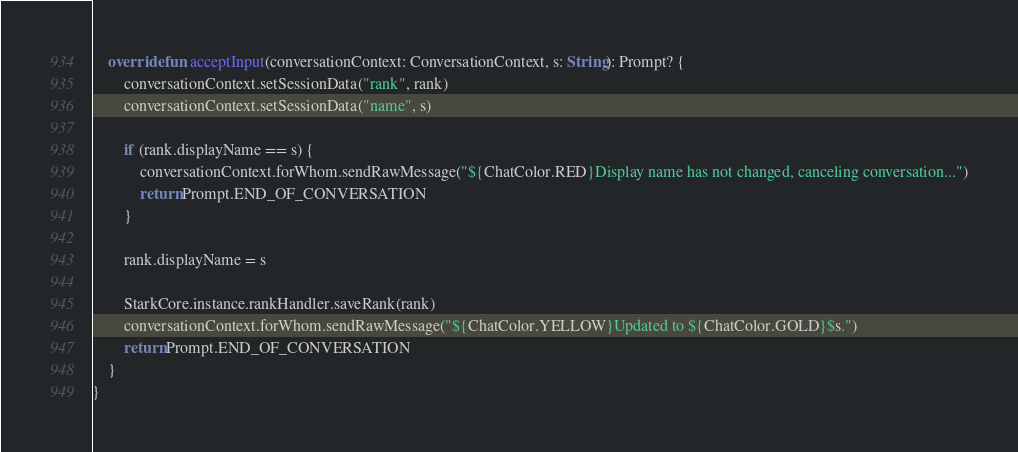<code> <loc_0><loc_0><loc_500><loc_500><_Kotlin_>
    override fun acceptInput(conversationContext: ConversationContext, s: String): Prompt? {
        conversationContext.setSessionData("rank", rank)
        conversationContext.setSessionData("name", s)

        if (rank.displayName == s) {
            conversationContext.forWhom.sendRawMessage("${ChatColor.RED}Display name has not changed, canceling conversation...")
            return Prompt.END_OF_CONVERSATION
        }

        rank.displayName = s

        StarkCore.instance.rankHandler.saveRank(rank)
        conversationContext.forWhom.sendRawMessage("${ChatColor.YELLOW}Updated to ${ChatColor.GOLD}$s.")
        return Prompt.END_OF_CONVERSATION
    }
}</code> 